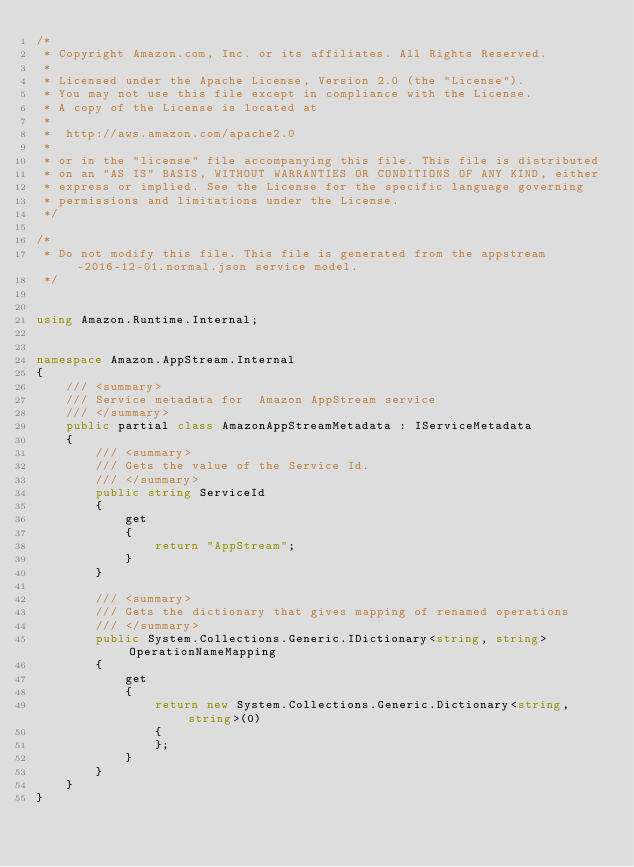<code> <loc_0><loc_0><loc_500><loc_500><_C#_>/*
 * Copyright Amazon.com, Inc. or its affiliates. All Rights Reserved.
 * 
 * Licensed under the Apache License, Version 2.0 (the "License").
 * You may not use this file except in compliance with the License.
 * A copy of the License is located at
 * 
 *  http://aws.amazon.com/apache2.0
 * 
 * or in the "license" file accompanying this file. This file is distributed
 * on an "AS IS" BASIS, WITHOUT WARRANTIES OR CONDITIONS OF ANY KIND, either
 * express or implied. See the License for the specific language governing
 * permissions and limitations under the License.
 */

/*
 * Do not modify this file. This file is generated from the appstream-2016-12-01.normal.json service model.
 */


using Amazon.Runtime.Internal;


namespace Amazon.AppStream.Internal
{
    /// <summary>
    /// Service metadata for  Amazon AppStream service
    /// </summary>
    public partial class AmazonAppStreamMetadata : IServiceMetadata
    {
        /// <summary>
        /// Gets the value of the Service Id.
        /// </summary>
        public string ServiceId
        {
            get
            {
                return "AppStream";
            }
        }

        /// <summary>
        /// Gets the dictionary that gives mapping of renamed operations
        /// </summary>
        public System.Collections.Generic.IDictionary<string, string> OperationNameMapping
        {
            get
            {
                return new System.Collections.Generic.Dictionary<string, string>(0)
                {
                };
            }
        }
    }
}</code> 